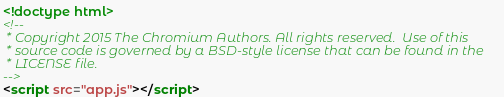Convert code to text. <code><loc_0><loc_0><loc_500><loc_500><_HTML_><!doctype html>
<!--
 * Copyright 2015 The Chromium Authors. All rights reserved.  Use of this
 * source code is governed by a BSD-style license that can be found in the
 * LICENSE file.
-->
<script src="app.js"></script>
</code> 